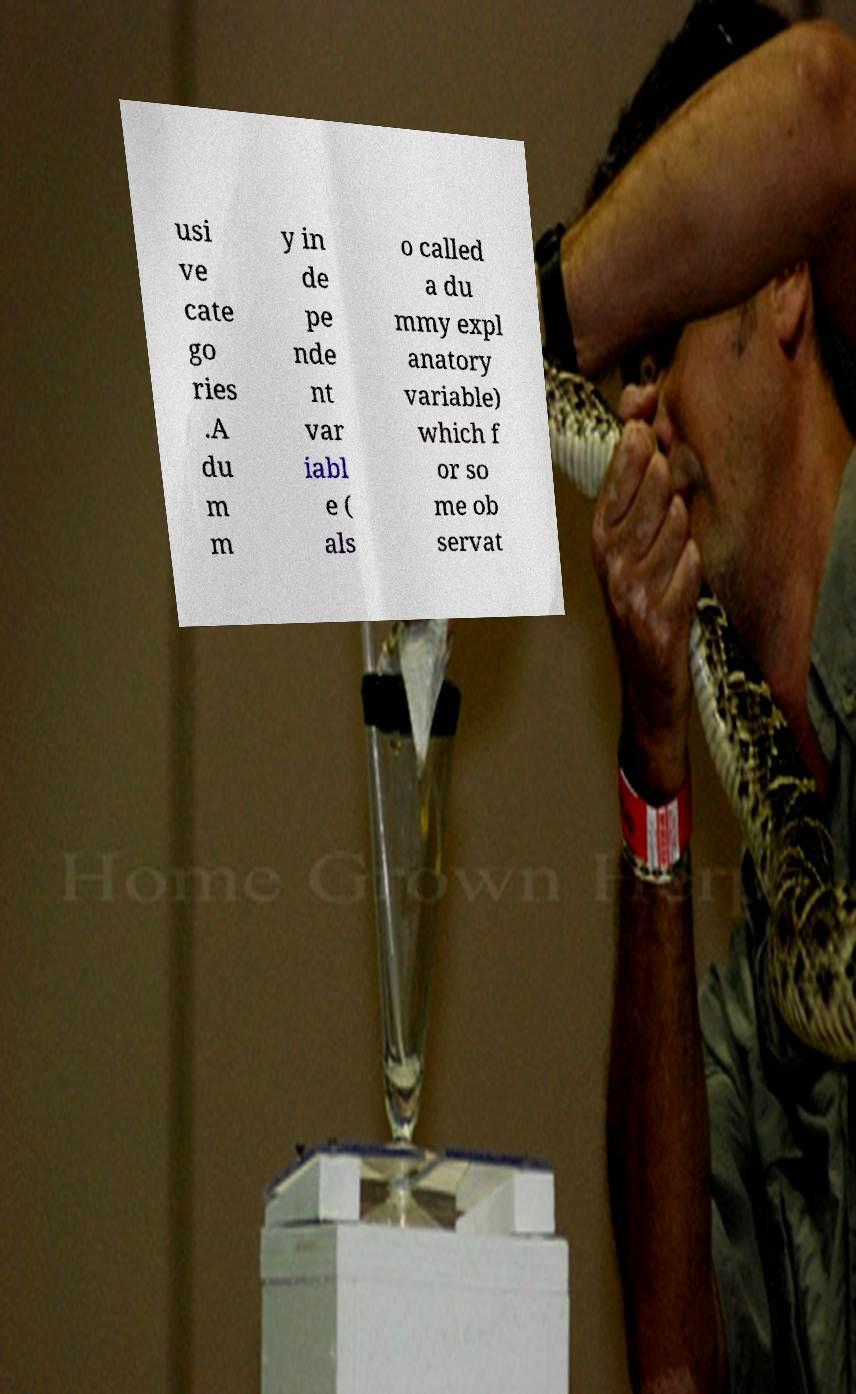Please read and relay the text visible in this image. What does it say? usi ve cate go ries .A du m m y in de pe nde nt var iabl e ( als o called a du mmy expl anatory variable) which f or so me ob servat 